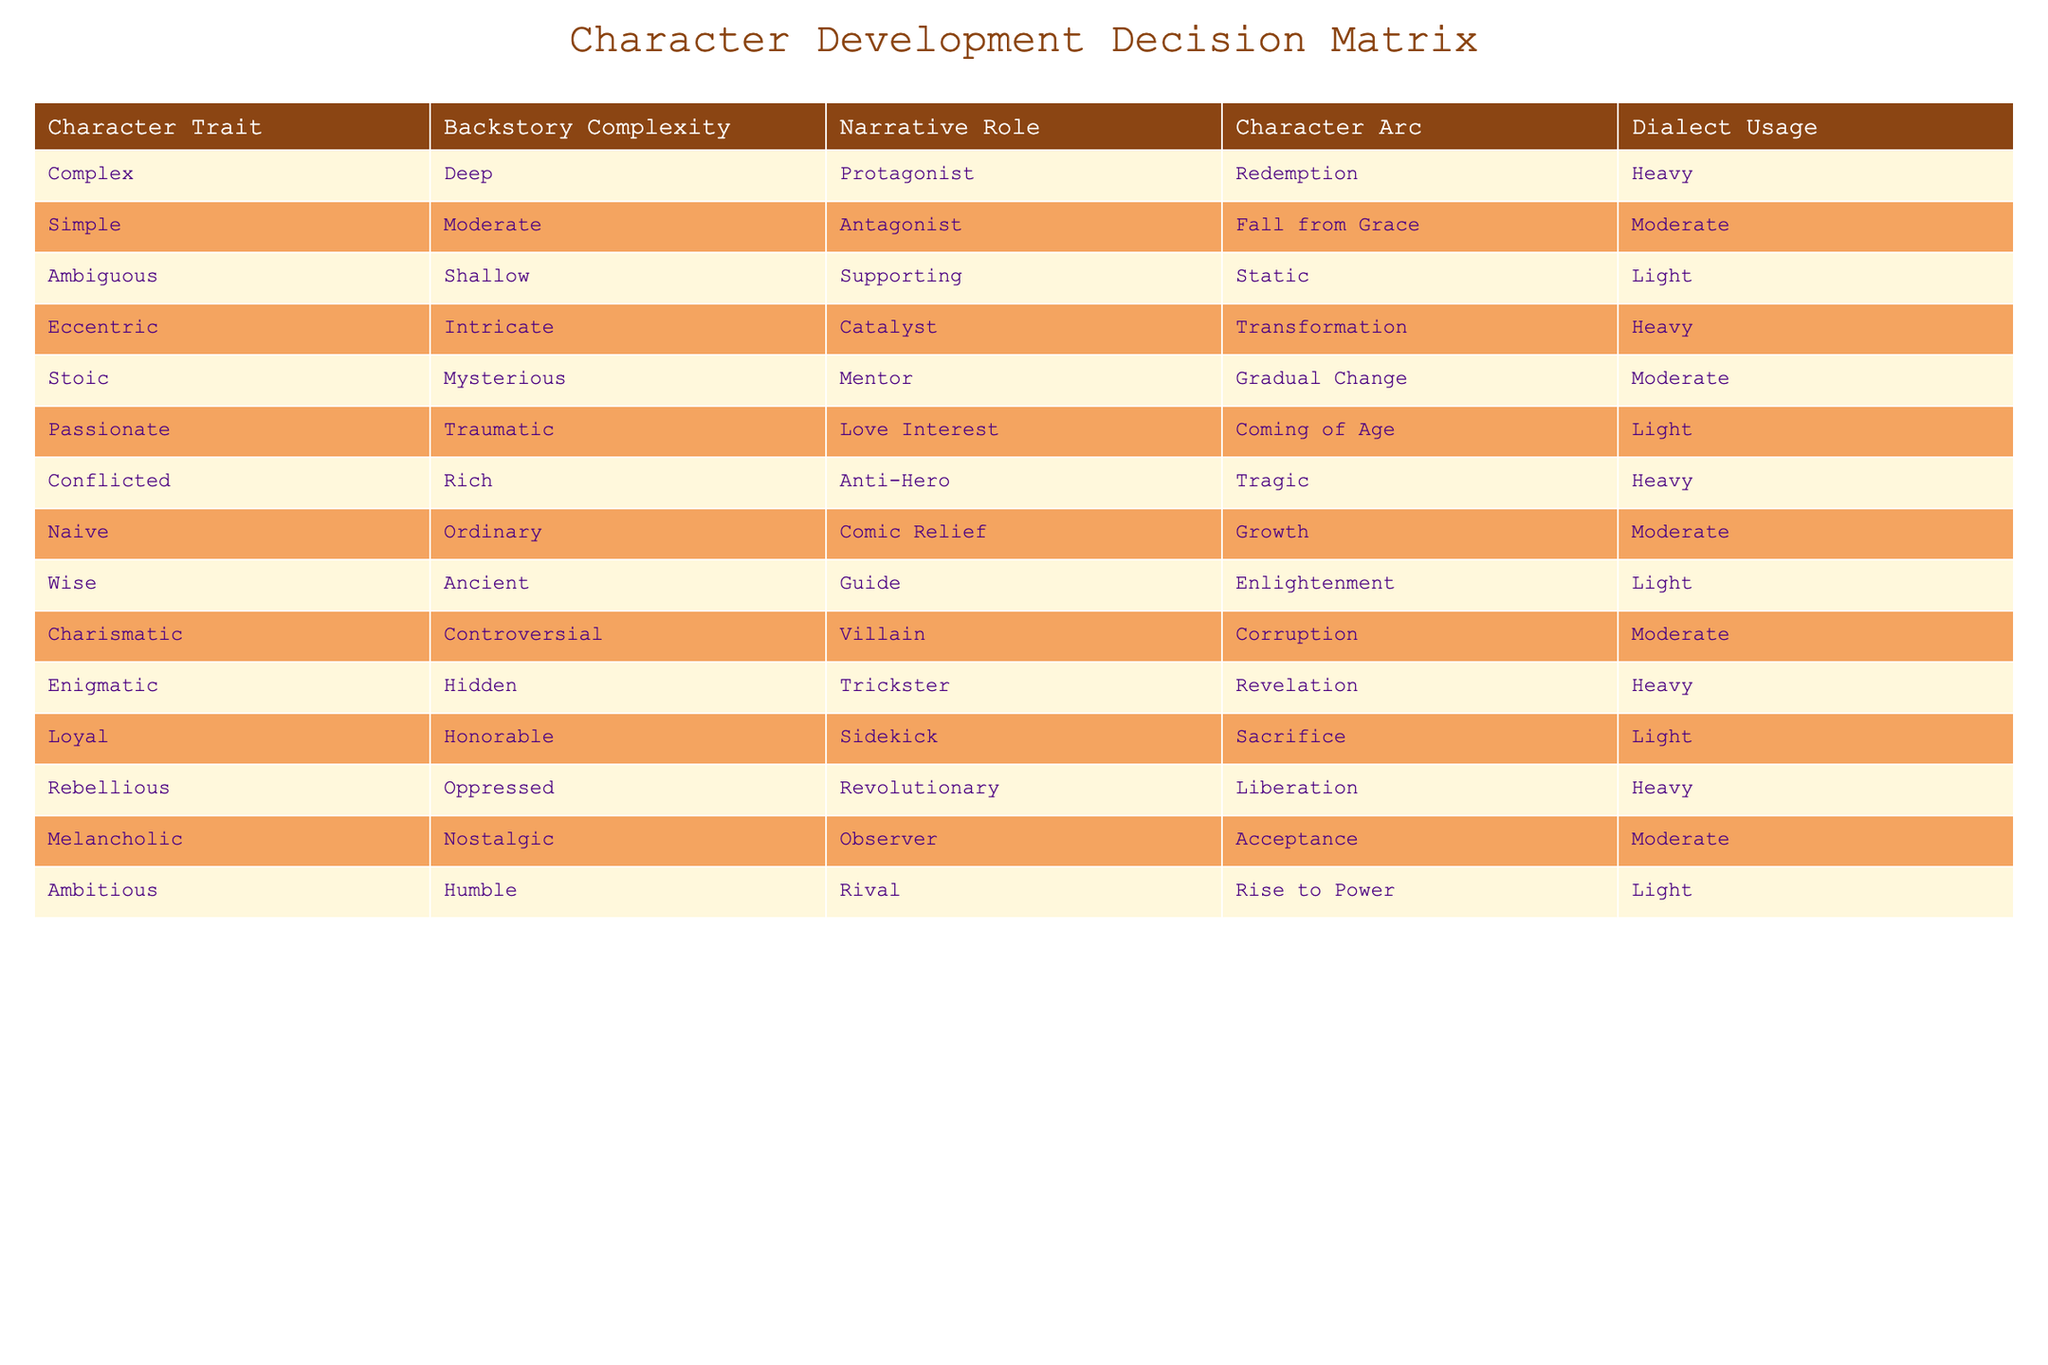What character has the most complex backstory? The table lists characters with different backstories. The complexity of the backstory is rated on a scale, and only "Eccentric" with "Intricate" and "Conflicted" with "Rich" appear to have the highest complexity, but since "Eccentric" is categorized as "Catalyst" we note the focus on role and not just complexity alone here. However, we also find nuances in "Complex" whose backstory listed as "Deep" ties strongly to a profound role as a protagonist, suggesting it’s pivotal in character's depth.
Answer: Complex Which character is the love interest and what is their arc? The table shows that "Passionate" is the character who serves as the love interest with a "Coming of Age" character arc. This matches the narrative requirement frequently employed for love interests, where transformation through emotional experiences usually occurs.
Answer: Passionate, Coming of Age Are there any characters that use a heavy dialect and are part of the mentor or guide roles? Scanning through the table, "Stoic" appears as a mentor but has a moderate dialect usage, while "Wise" is designated as a guide with light dialect presence. Therefore, there are no characters in the mentor or guide roles that have a heavy dialect usage according to the characteristics outlined.
Answer: No What is the average number of characters that have a narrative role of antagonist? The table indicates that there is only one character designated as an antagonist: "Simple". Thus the average also corresponds to that singular entry, showcasing no variance here. This signifies that in this specific character matrix, the antagonistic role is less diverse.
Answer: 1 Which character experiences a tragic arc and how complex is their backstory? The character "Conflicted" is described as having a tragic arc, which directly signals a depth in emotional complexity, and their backstory complexity being rich signifies a profound narrative purpose, combining qualities that could engage a reader. Thus, there lies a notable contrast even among protagonists and anti-heroes in narrative depth.
Answer: Conflicted, Rich 